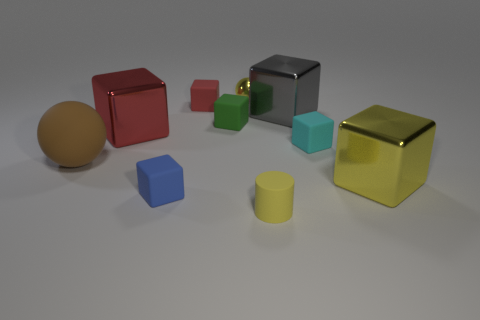Subtract all tiny red cubes. How many cubes are left? 6 Subtract all balls. How many objects are left? 8 Subtract all blue balls. How many red cubes are left? 2 Subtract all yellow balls. How many balls are left? 1 Subtract 1 spheres. How many spheres are left? 1 Add 5 small yellow rubber blocks. How many small yellow rubber blocks exist? 5 Subtract 2 red cubes. How many objects are left? 8 Subtract all brown spheres. Subtract all gray cylinders. How many spheres are left? 1 Subtract all large blue metallic spheres. Subtract all gray blocks. How many objects are left? 9 Add 1 balls. How many balls are left? 3 